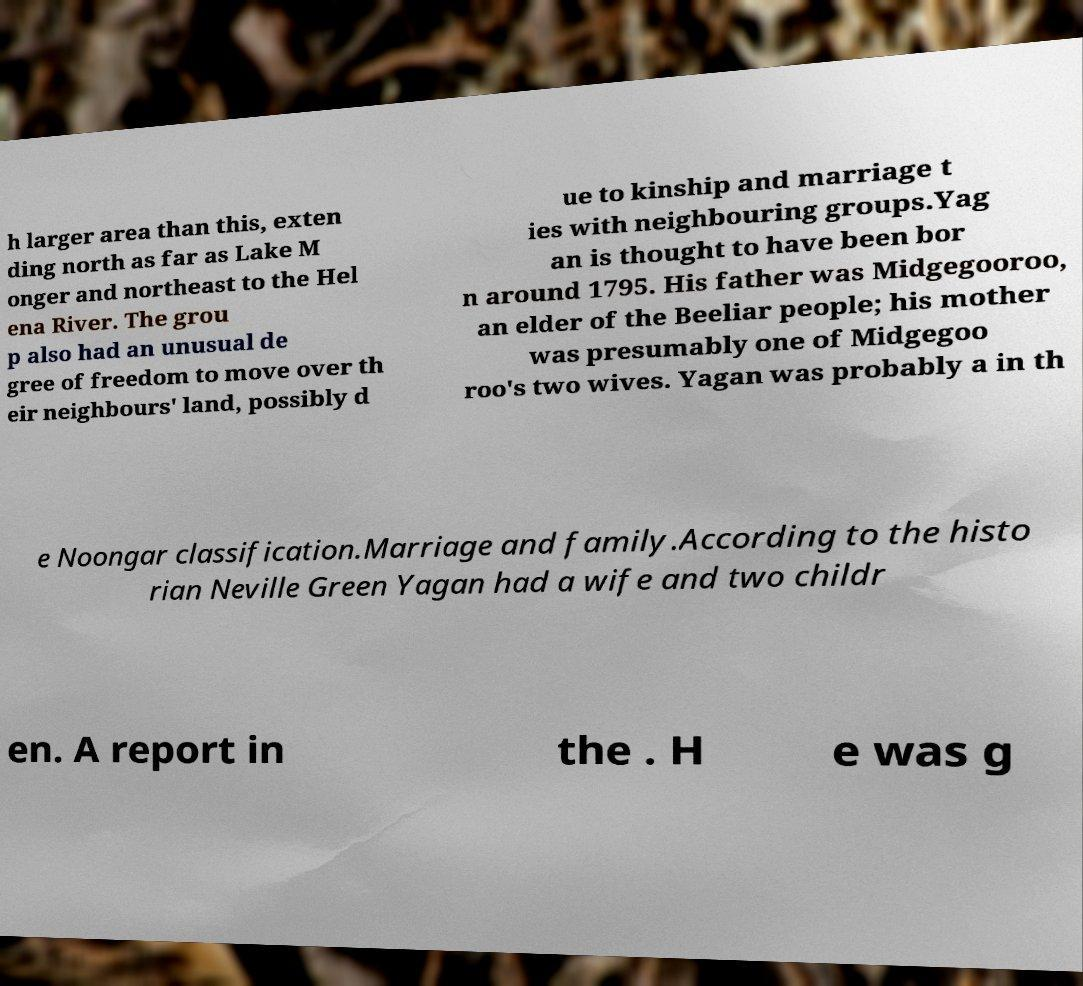For documentation purposes, I need the text within this image transcribed. Could you provide that? h larger area than this, exten ding north as far as Lake M onger and northeast to the Hel ena River. The grou p also had an unusual de gree of freedom to move over th eir neighbours' land, possibly d ue to kinship and marriage t ies with neighbouring groups.Yag an is thought to have been bor n around 1795. His father was Midgegooroo, an elder of the Beeliar people; his mother was presumably one of Midgegoo roo's two wives. Yagan was probably a in th e Noongar classification.Marriage and family.According to the histo rian Neville Green Yagan had a wife and two childr en. A report in the . H e was g 